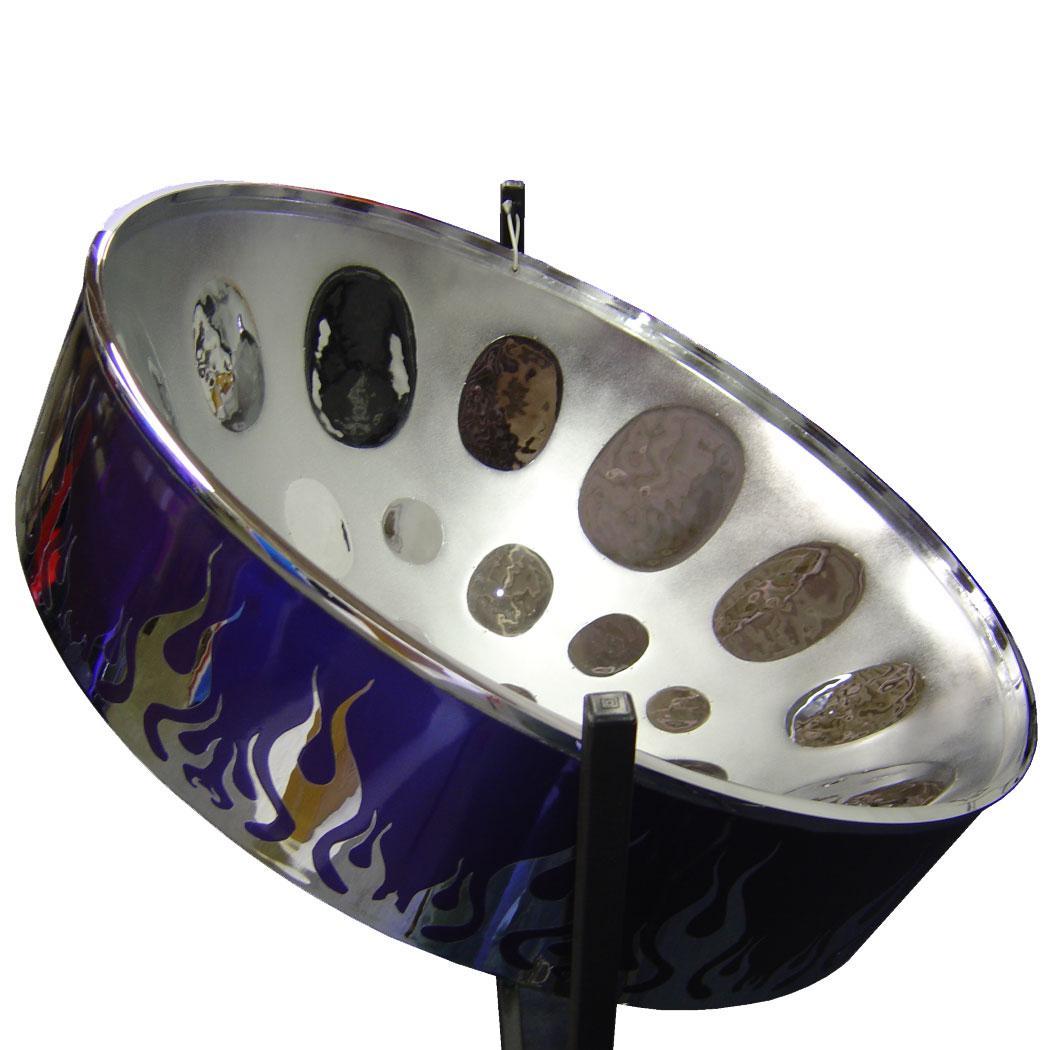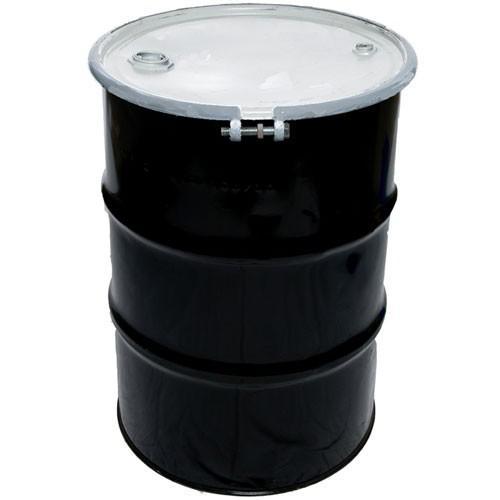The first image is the image on the left, the second image is the image on the right. For the images displayed, is the sentence "In at least one image there is a black metal barrel with a lid on." factually correct? Answer yes or no. Yes. 